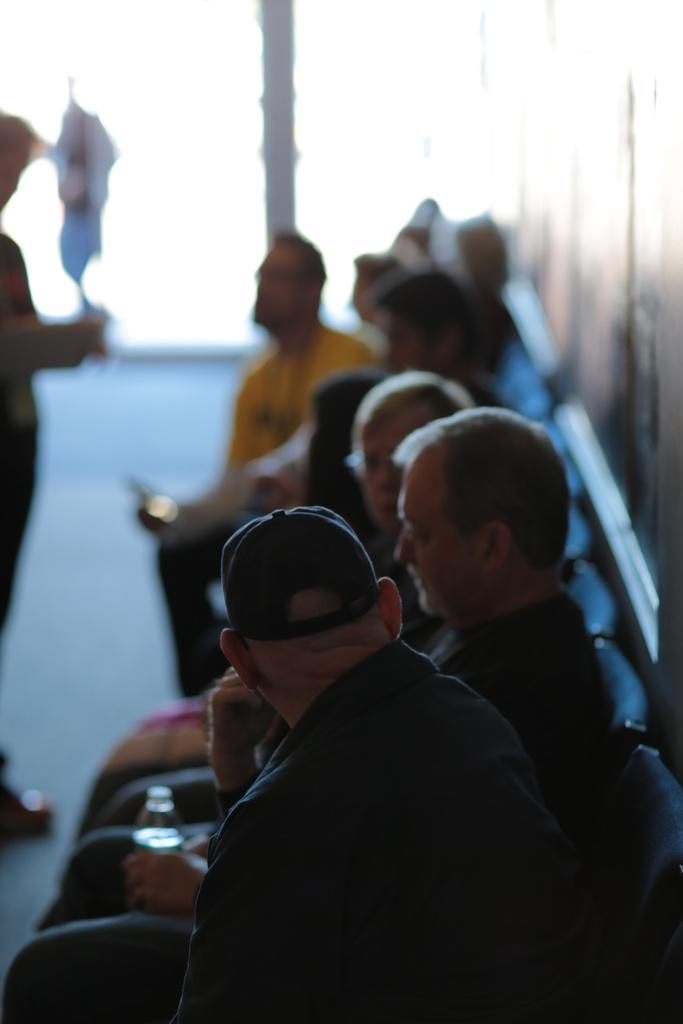Who or what can be seen in the image? There are people in the image. What are the people doing in the image? The people are sitting in chairs. Can you describe the background of the image? The background of the image is blurred. What type of toy can be seen in the image? There is no toy present in the image. Is there a club visible in the image? There is no club present in the image. 